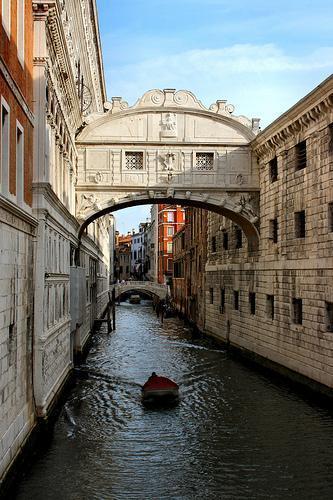How many boats are in the water?
Give a very brief answer. 1. 